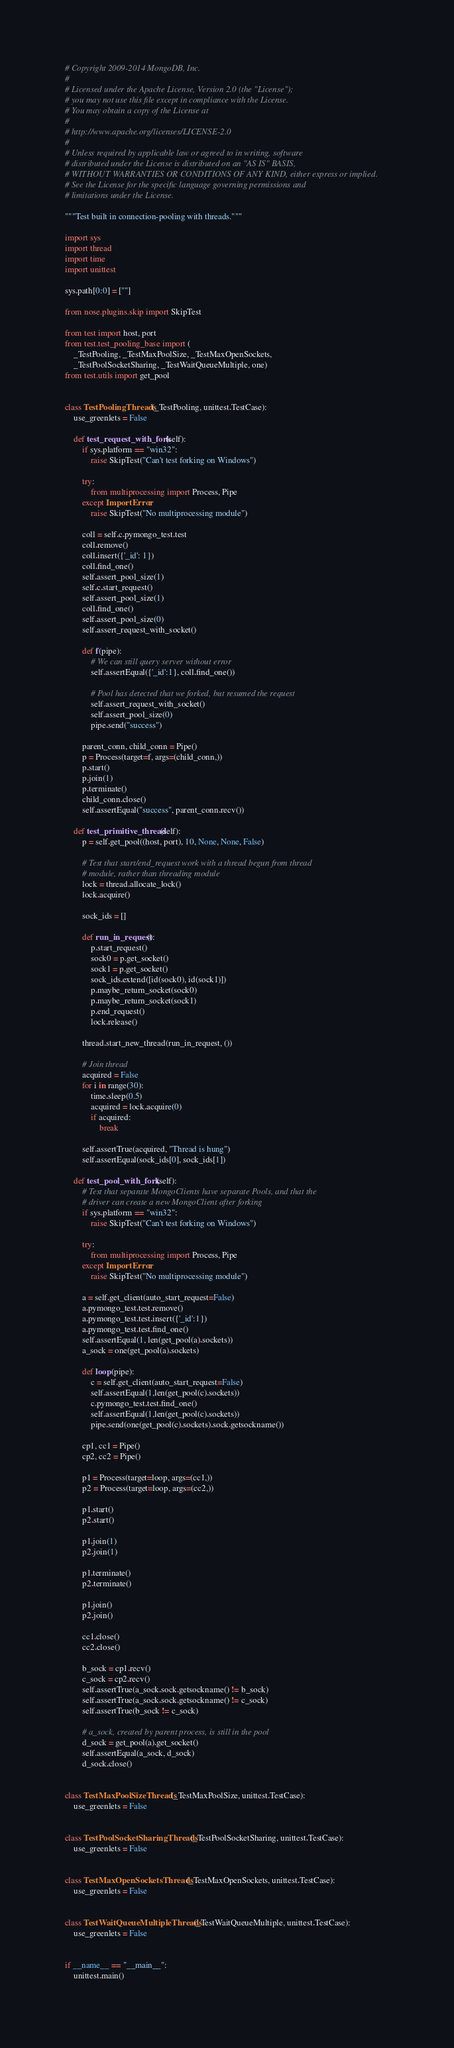Convert code to text. <code><loc_0><loc_0><loc_500><loc_500><_Python_># Copyright 2009-2014 MongoDB, Inc.
#
# Licensed under the Apache License, Version 2.0 (the "License");
# you may not use this file except in compliance with the License.
# You may obtain a copy of the License at
#
# http://www.apache.org/licenses/LICENSE-2.0
#
# Unless required by applicable law or agreed to in writing, software
# distributed under the License is distributed on an "AS IS" BASIS,
# WITHOUT WARRANTIES OR CONDITIONS OF ANY KIND, either express or implied.
# See the License for the specific language governing permissions and
# limitations under the License.

"""Test built in connection-pooling with threads."""

import sys
import thread
import time
import unittest

sys.path[0:0] = [""]

from nose.plugins.skip import SkipTest

from test import host, port
from test.test_pooling_base import (
    _TestPooling, _TestMaxPoolSize, _TestMaxOpenSockets,
    _TestPoolSocketSharing, _TestWaitQueueMultiple, one)
from test.utils import get_pool


class TestPoolingThreads(_TestPooling, unittest.TestCase):
    use_greenlets = False

    def test_request_with_fork(self):
        if sys.platform == "win32":
            raise SkipTest("Can't test forking on Windows")

        try:
            from multiprocessing import Process, Pipe
        except ImportError:
            raise SkipTest("No multiprocessing module")

        coll = self.c.pymongo_test.test
        coll.remove()
        coll.insert({'_id': 1})
        coll.find_one()
        self.assert_pool_size(1)
        self.c.start_request()
        self.assert_pool_size(1)
        coll.find_one()
        self.assert_pool_size(0)
        self.assert_request_with_socket()

        def f(pipe):
            # We can still query server without error
            self.assertEqual({'_id':1}, coll.find_one())

            # Pool has detected that we forked, but resumed the request
            self.assert_request_with_socket()
            self.assert_pool_size(0)
            pipe.send("success")

        parent_conn, child_conn = Pipe()
        p = Process(target=f, args=(child_conn,))
        p.start()
        p.join(1)
        p.terminate()
        child_conn.close()
        self.assertEqual("success", parent_conn.recv())

    def test_primitive_thread(self):
        p = self.get_pool((host, port), 10, None, None, False)

        # Test that start/end_request work with a thread begun from thread
        # module, rather than threading module
        lock = thread.allocate_lock()
        lock.acquire()

        sock_ids = []

        def run_in_request():
            p.start_request()
            sock0 = p.get_socket()
            sock1 = p.get_socket()
            sock_ids.extend([id(sock0), id(sock1)])
            p.maybe_return_socket(sock0)
            p.maybe_return_socket(sock1)
            p.end_request()
            lock.release()

        thread.start_new_thread(run_in_request, ())

        # Join thread
        acquired = False
        for i in range(30):
            time.sleep(0.5)
            acquired = lock.acquire(0)
            if acquired:
                break

        self.assertTrue(acquired, "Thread is hung")
        self.assertEqual(sock_ids[0], sock_ids[1])

    def test_pool_with_fork(self):
        # Test that separate MongoClients have separate Pools, and that the
        # driver can create a new MongoClient after forking
        if sys.platform == "win32":
            raise SkipTest("Can't test forking on Windows")

        try:
            from multiprocessing import Process, Pipe
        except ImportError:
            raise SkipTest("No multiprocessing module")

        a = self.get_client(auto_start_request=False)
        a.pymongo_test.test.remove()
        a.pymongo_test.test.insert({'_id':1})
        a.pymongo_test.test.find_one()
        self.assertEqual(1, len(get_pool(a).sockets))
        a_sock = one(get_pool(a).sockets)

        def loop(pipe):
            c = self.get_client(auto_start_request=False)
            self.assertEqual(1,len(get_pool(c).sockets))
            c.pymongo_test.test.find_one()
            self.assertEqual(1,len(get_pool(c).sockets))
            pipe.send(one(get_pool(c).sockets).sock.getsockname())

        cp1, cc1 = Pipe()
        cp2, cc2 = Pipe()

        p1 = Process(target=loop, args=(cc1,))
        p2 = Process(target=loop, args=(cc2,))

        p1.start()
        p2.start()

        p1.join(1)
        p2.join(1)

        p1.terminate()
        p2.terminate()

        p1.join()
        p2.join()

        cc1.close()
        cc2.close()

        b_sock = cp1.recv()
        c_sock = cp2.recv()
        self.assertTrue(a_sock.sock.getsockname() != b_sock)
        self.assertTrue(a_sock.sock.getsockname() != c_sock)
        self.assertTrue(b_sock != c_sock)

        # a_sock, created by parent process, is still in the pool
        d_sock = get_pool(a).get_socket()
        self.assertEqual(a_sock, d_sock)
        d_sock.close()


class TestMaxPoolSizeThreads(_TestMaxPoolSize, unittest.TestCase):
    use_greenlets = False


class TestPoolSocketSharingThreads(_TestPoolSocketSharing, unittest.TestCase):
    use_greenlets = False


class TestMaxOpenSocketsThreads(_TestMaxOpenSockets, unittest.TestCase):
    use_greenlets = False


class TestWaitQueueMultipleThreads(_TestWaitQueueMultiple, unittest.TestCase):
    use_greenlets = False


if __name__ == "__main__":
    unittest.main()
</code> 